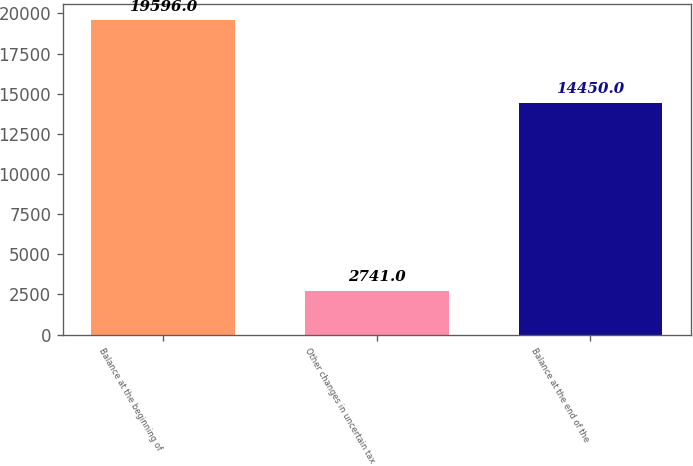<chart> <loc_0><loc_0><loc_500><loc_500><bar_chart><fcel>Balance at the beginning of<fcel>Other changes in uncertain tax<fcel>Balance at the end of the<nl><fcel>19596<fcel>2741<fcel>14450<nl></chart> 